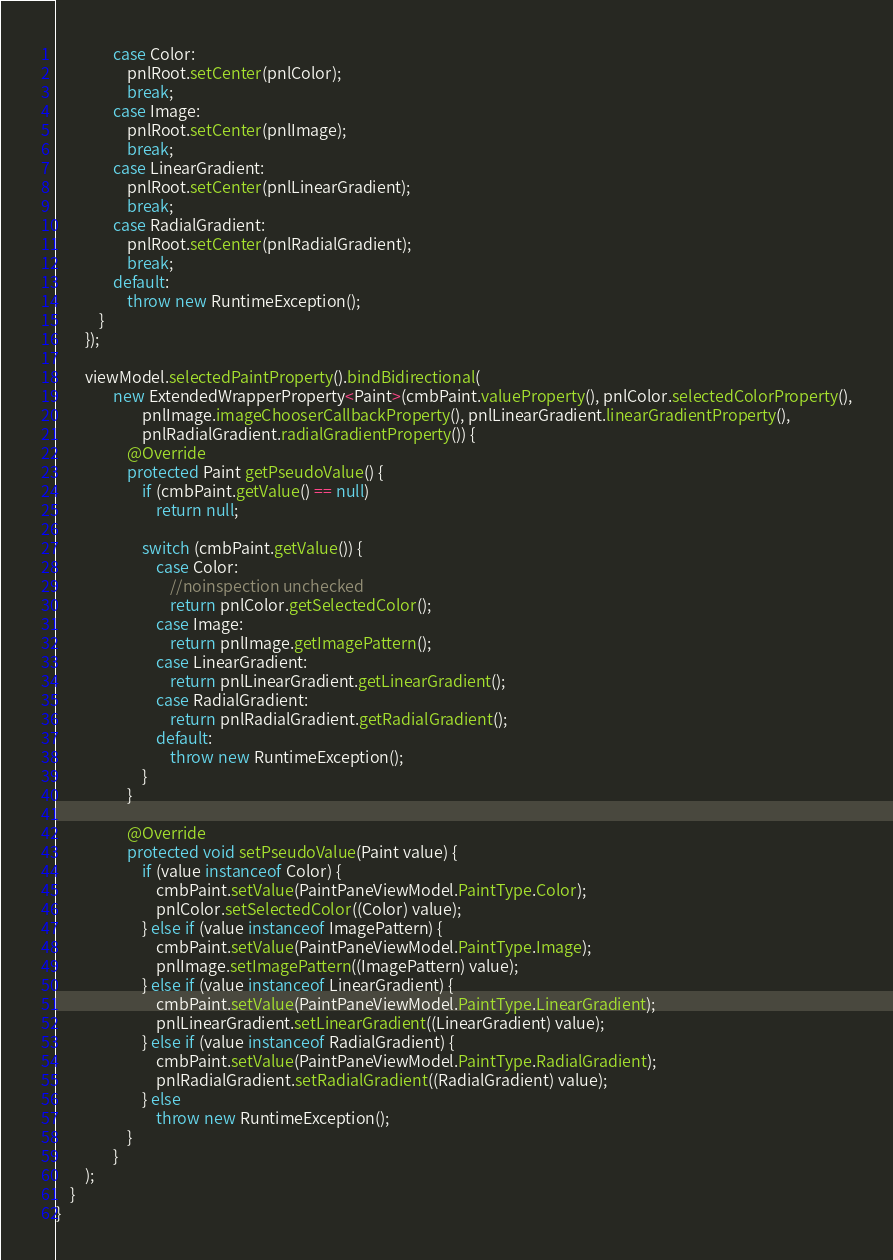<code> <loc_0><loc_0><loc_500><loc_500><_Java_>                case Color:
                    pnlRoot.setCenter(pnlColor);
                    break;
                case Image:
                    pnlRoot.setCenter(pnlImage);
                    break;
                case LinearGradient:
                    pnlRoot.setCenter(pnlLinearGradient);
                    break;
                case RadialGradient:
                    pnlRoot.setCenter(pnlRadialGradient);
                    break;
                default:
                    throw new RuntimeException();
            }
        });

        viewModel.selectedPaintProperty().bindBidirectional(
                new ExtendedWrapperProperty<Paint>(cmbPaint.valueProperty(), pnlColor.selectedColorProperty(),
                        pnlImage.imageChooserCallbackProperty(), pnlLinearGradient.linearGradientProperty(),
                        pnlRadialGradient.radialGradientProperty()) {
                    @Override
                    protected Paint getPseudoValue() {
                        if (cmbPaint.getValue() == null)
                            return null;

                        switch (cmbPaint.getValue()) {
                            case Color:
                                //noinspection unchecked
                                return pnlColor.getSelectedColor();
                            case Image:
                                return pnlImage.getImagePattern();
                            case LinearGradient:
                                return pnlLinearGradient.getLinearGradient();
                            case RadialGradient:
                                return pnlRadialGradient.getRadialGradient();
                            default:
                                throw new RuntimeException();
                        }
                    }

                    @Override
                    protected void setPseudoValue(Paint value) {
                        if (value instanceof Color) {
                            cmbPaint.setValue(PaintPaneViewModel.PaintType.Color);
                            pnlColor.setSelectedColor((Color) value);
                        } else if (value instanceof ImagePattern) {
                            cmbPaint.setValue(PaintPaneViewModel.PaintType.Image);
                            pnlImage.setImagePattern((ImagePattern) value);
                        } else if (value instanceof LinearGradient) {
                            cmbPaint.setValue(PaintPaneViewModel.PaintType.LinearGradient);
                            pnlLinearGradient.setLinearGradient((LinearGradient) value);
                        } else if (value instanceof RadialGradient) {
                            cmbPaint.setValue(PaintPaneViewModel.PaintType.RadialGradient);
                            pnlRadialGradient.setRadialGradient((RadialGradient) value);
                        } else
                            throw new RuntimeException();
                    }
                }
        );
    }
}
</code> 